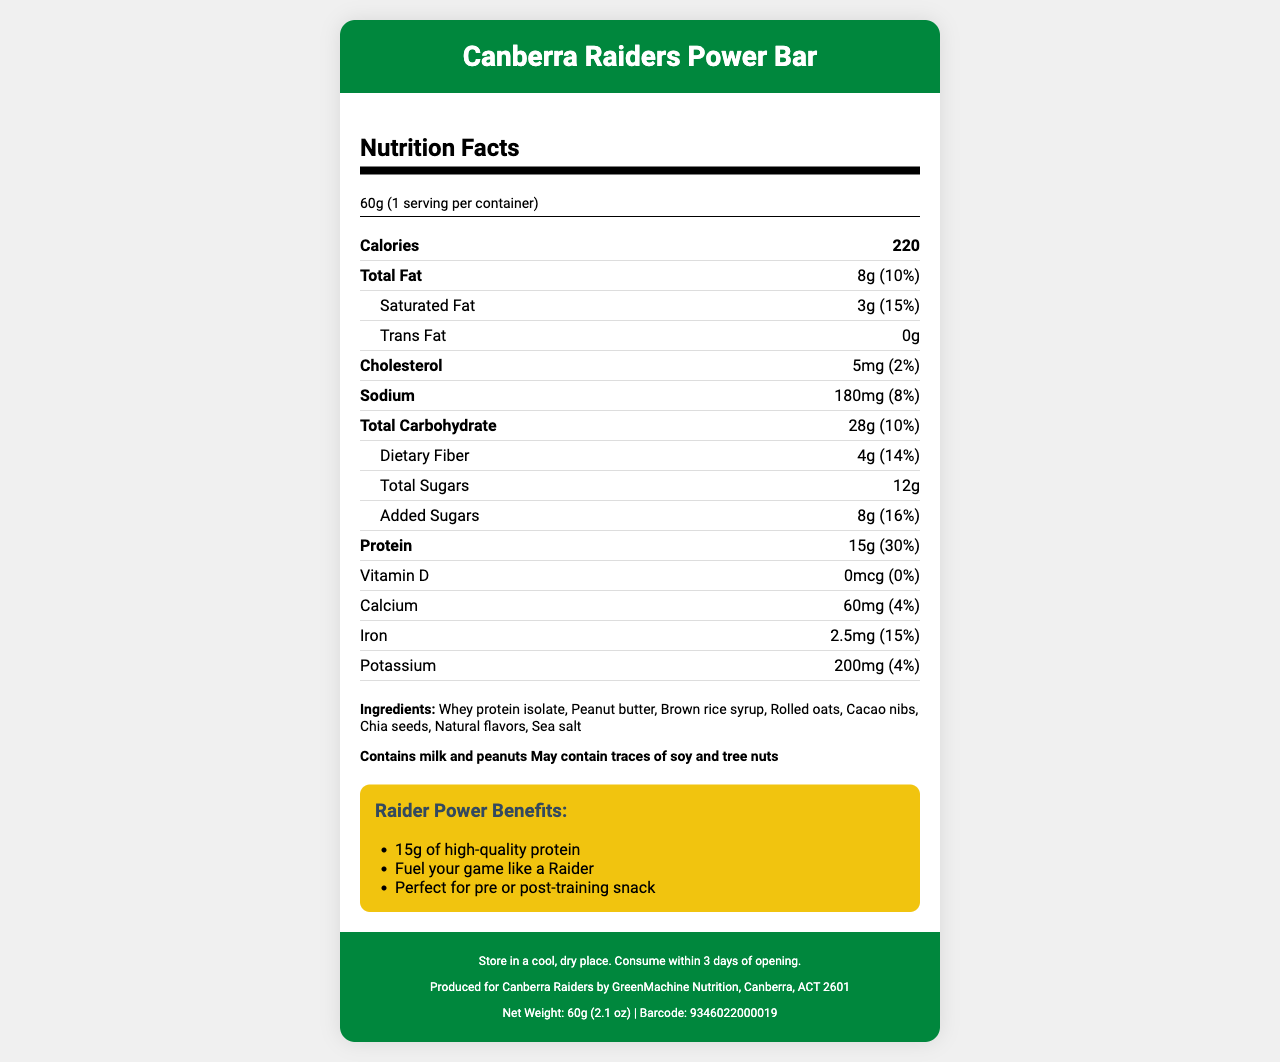what is the serving size of the Canberra Raiders Power Bar? The serving size is explicitly mentioned as "60g" in the serving info section of the document.
Answer: 60g How many calories are there per serving? The calories per serving are shown as "220" in the bold nutrient row at the top of the nutrition facts section.
Answer: 220 what is the amount of protein per serving? The amount of protein is listed as "15g" in the section for protein.
Answer: 15g What percentage of daily value does the added sugars contribute? The document specifies that the added sugars contribute "16%" of the daily value in the nutrition facts section.
Answer: 16% How much iron does the Canberra Raiders Power Bar contain? The iron content is listed as "2.5mg" along with its percent daily value of "15%".
Answer: 2.5mg How many grams of dietary fiber are there per serving? The amount of dietary fiber is "4g" with a percent daily value of "14%".
Answer: 4g Does the bar contain trans fat? The document specifies that the trans fat amount is "0g".
Answer: No is there vitamin D in this protein bar? The document shows the amount of Vitamin D as "0mcg" with a percent daily value of "0%".
Answer: No which allergen is not mentioned in the ingredients? A. Milk B. Peanuts C. Soy Soy is mentioned as "may contain traces," not as a main ingredient.
Answer: C What is the net weight of the Canberra Raiders Power Bar? A. 50g B. 60g C. 70g D. 80g The net weight is shown as "60g (2.1 oz)" in the footer section of the document.
Answer: B Where is the Canberra Raiders Power Bar manufactured? I. Sydney, NSW II. Canberra, ACT III. Melbourne, VIC IV. Brisbane, QLD The manufacturer info at the bottom of the document indicates Canberra, ACT.
Answer: II Is the Canberra Raiders Power Bar gluten-free? The document does not provide any information regarding the presence or absence of gluten.
Answer: Cannot be determined Summarize the main idea of the document The document is structured to present the nutritional facts, ingredients, allergens, marketing claims, storage instructions, and manufacturer info about the Canberra Raiders Power Bar, aimed at briefing potential consumers.
Answer: The document provides detailed nutritional information and marketing claims for the Canberra Raiders Power Bar. It includes data on serving size, calories, macronutrients, vitamins, and minerals, along with a list of ingredients and allergens. The bar is marketed as a high-protein snack suitable for pre or post-training consumption. Storage instructions and manufacturer information are also included. 